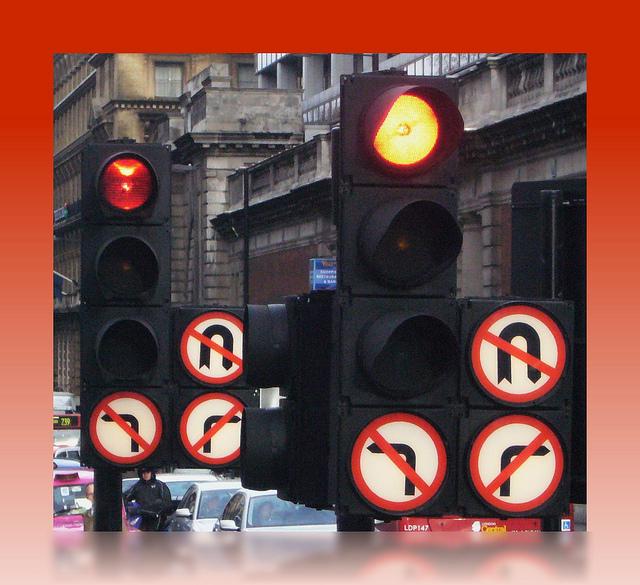What color is the left-most traffic displaying?
Write a very short answer. Red. Why is it illegal to make U-turns in certain times of day?
Concise answer only. Traffic. How far must the driver go before being allowed to turn?
Concise answer only. 1 block. 